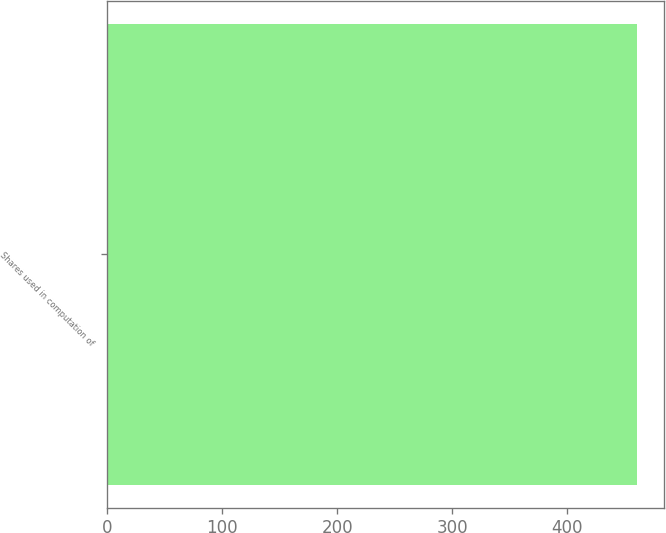<chart> <loc_0><loc_0><loc_500><loc_500><bar_chart><fcel>Shares used in computation of<nl><fcel>461<nl></chart> 